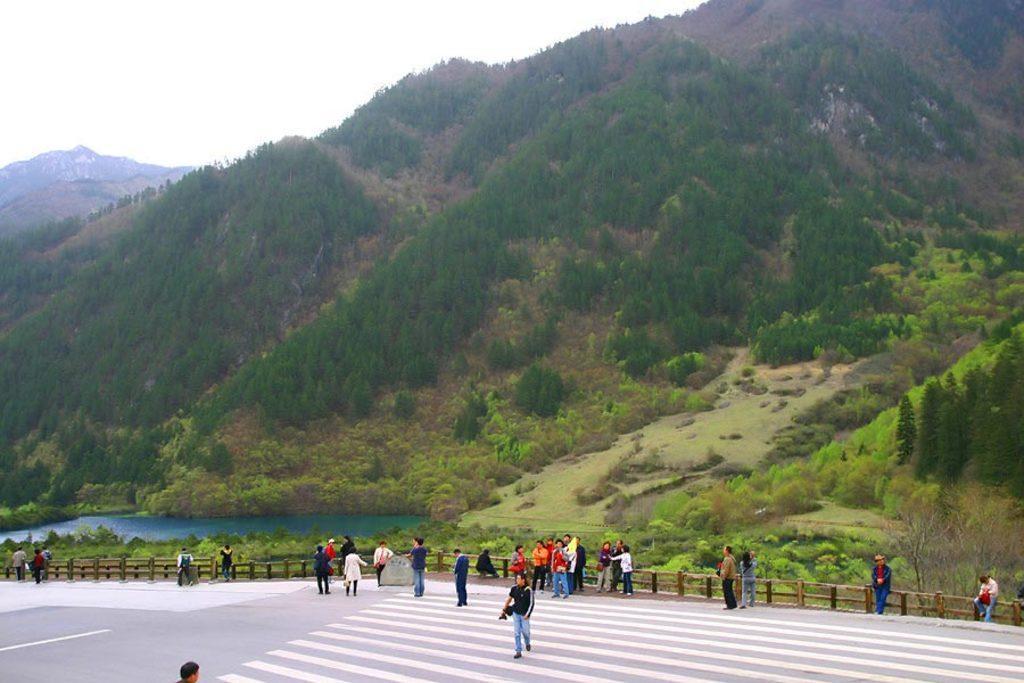How would you summarize this image in a sentence or two? This picture is taken from the outside of the city. In this image, in the middle, we can see a group of people. In the background, we can see water in a lake, plants, trees, rocks, mountains. At the top, we can see a sky, at the bottom, we can see some plants, grass and a road 